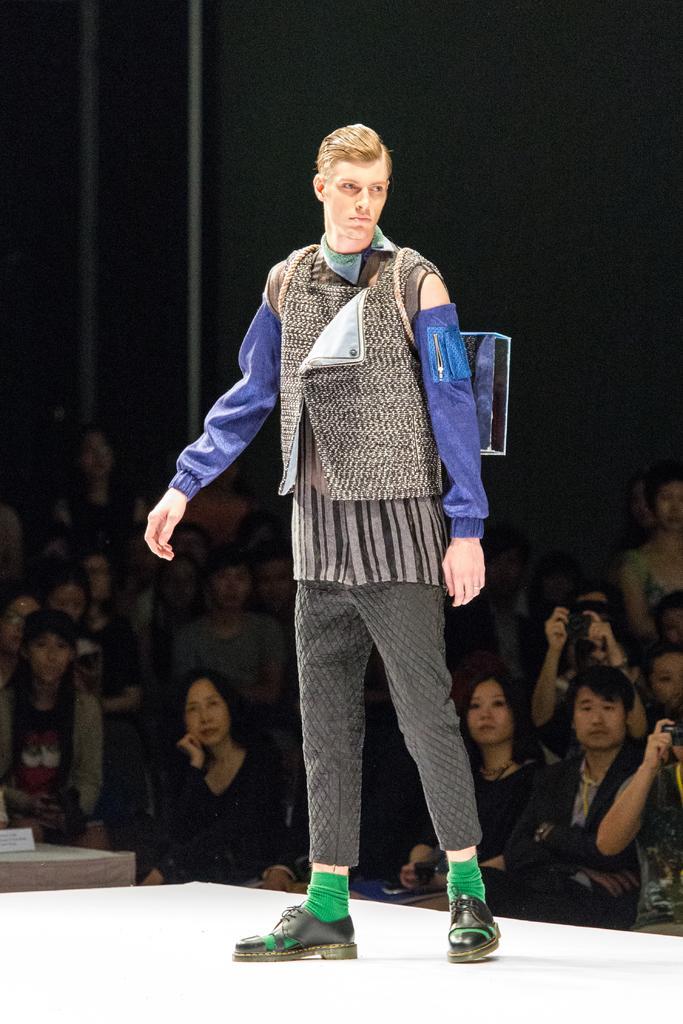How would you summarize this image in a sentence or two? In the center of the image we can see one person is standing on some object and he is in a different costume. And we can see a few people are sitting, few people are standing and a few people are holding some objects. On the left side of the image, we can see some objects. And we can see the dark background. 